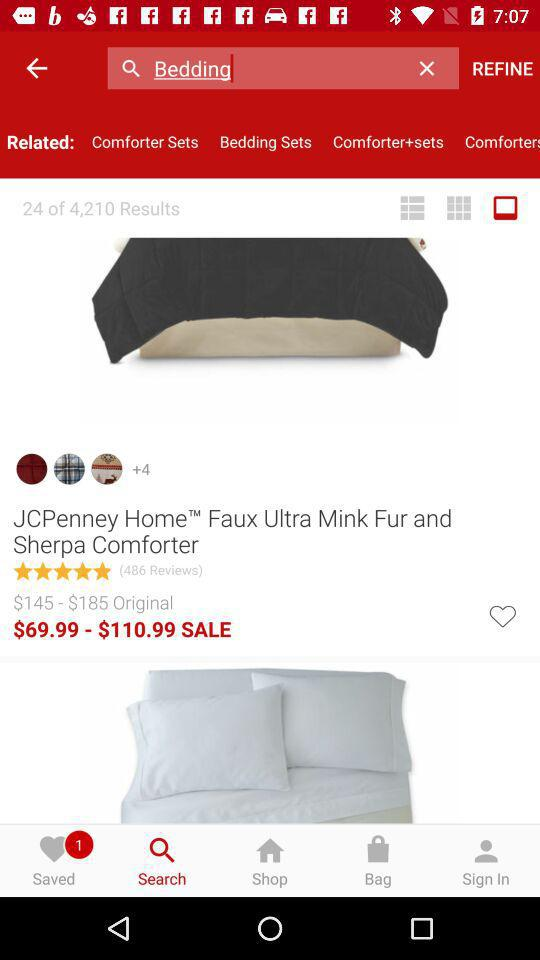How many notifications are pending in "Saved"? There is 1 notification pending in "Saved". 